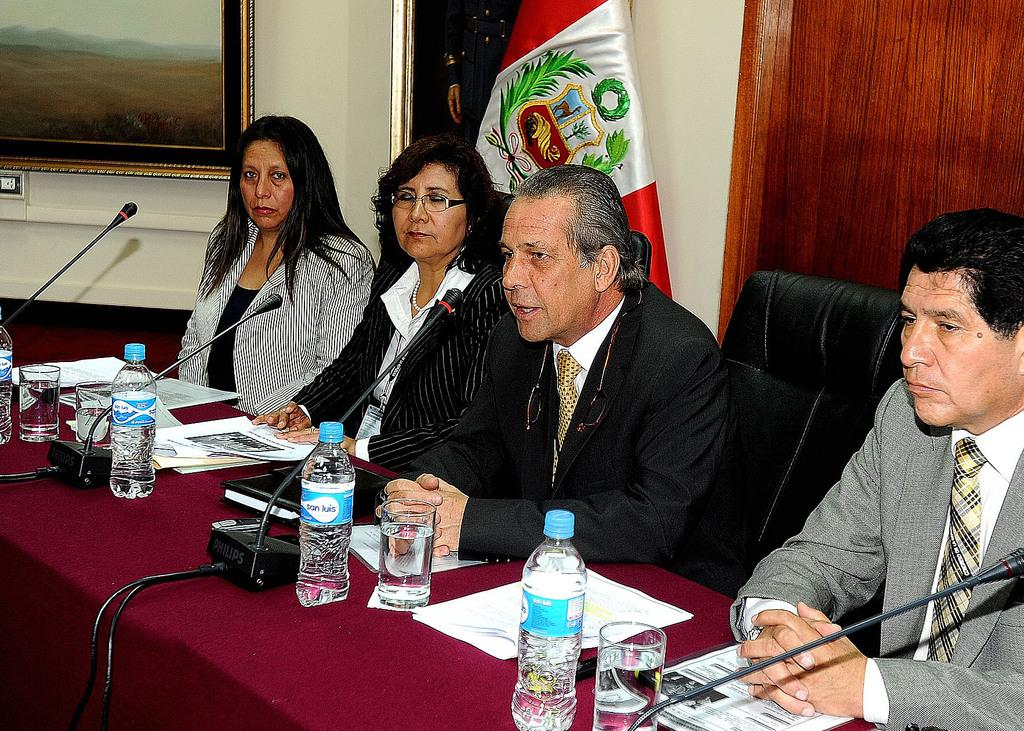Who or what is present in the image? There are people in the image. What are the people doing in the image? The people are sitting and speaking into a microphone. What object can be seen in the image besides the people? There is a table in the image. What type of disgust can be seen on the faces of the people in the image? There is no indication of disgust on the faces of the people in the image; they are simply sitting and speaking into a microphone. What scale is used to measure the temperature of the oven in the image? There is no oven present in the image, so it is not possible to determine the scale used for measuring temperature. 